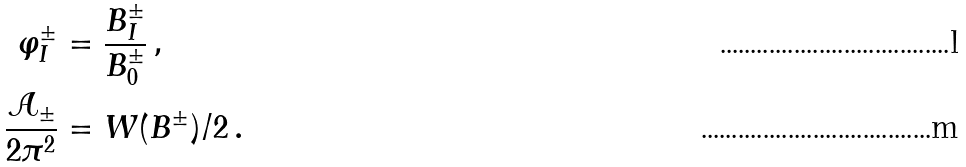<formula> <loc_0><loc_0><loc_500><loc_500>\varphi _ { I } ^ { \pm } & = \frac { B _ { I } ^ { \pm } } { B _ { 0 } ^ { \pm } } \, , \\ \frac { \mathcal { A } _ { \pm } } { 2 \pi ^ { 2 } } & = W ( B ^ { \pm } ) / 2 \, .</formula> 